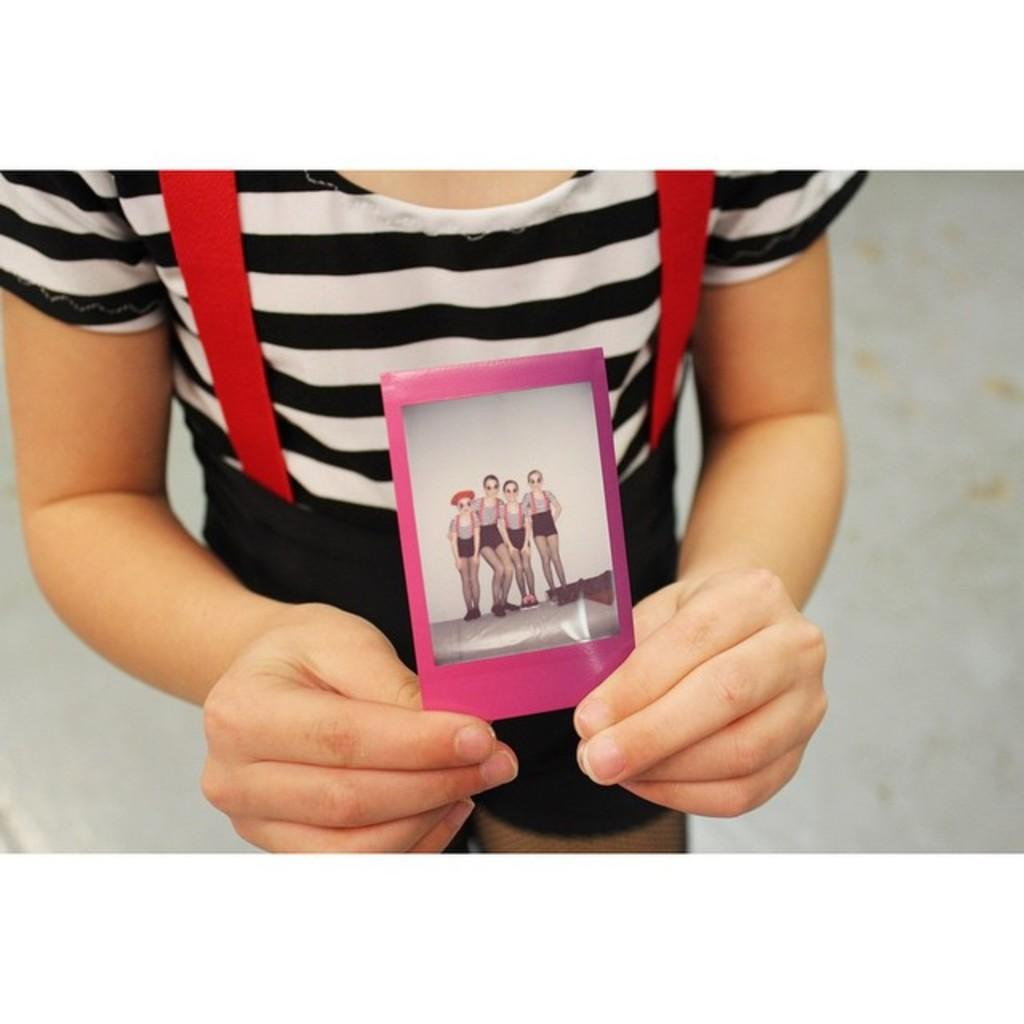What is the main subject of the image? There is a person standing in the image. Where is the person standing? The person is standing on the floor. What is the person holding in his hand? The person is holding a photo in his hand. How many persons are in the photo? The photo contains four persons. What are the four persons doing in the photo? The four persons are standing before a wall in the photo. What type of fire can be seen in the image? There is no fire present in the image. What kind of apparatus is being used by the person in the image? The person in the image is not using any apparatus; they are simply holding a photo. 